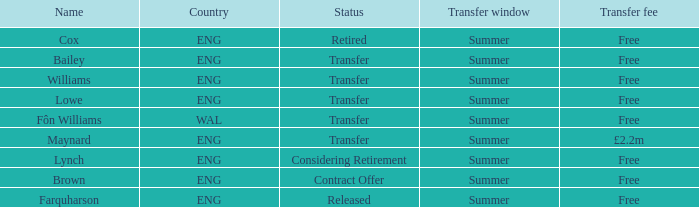What is the transfer window with a status of transfer from the country of Wal? Summer. 